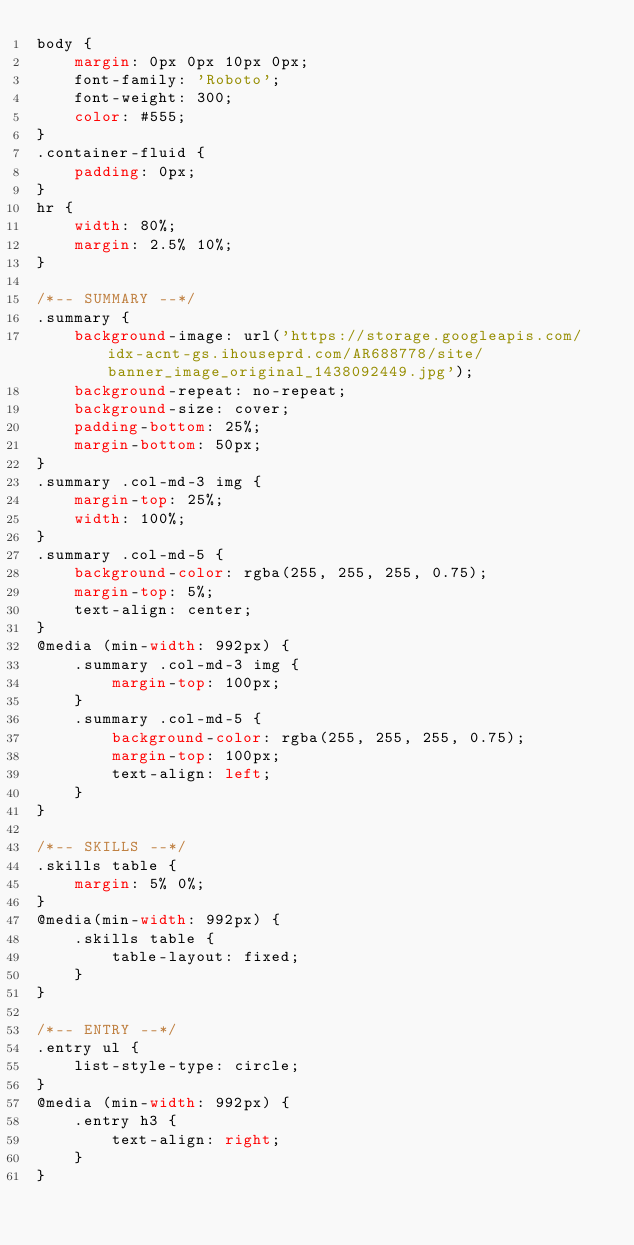<code> <loc_0><loc_0><loc_500><loc_500><_CSS_>body {
	margin: 0px 0px 10px 0px;
	font-family: 'Roboto';
	font-weight: 300;
	color: #555;
}
.container-fluid {
	padding: 0px;
}
hr {
	width: 80%;
	margin: 2.5% 10%;
}

/*-- SUMMARY --*/
.summary {
	background-image: url('https://storage.googleapis.com/idx-acnt-gs.ihouseprd.com/AR688778/site/banner_image_original_1438092449.jpg');
	background-repeat: no-repeat;
	background-size: cover;
	padding-bottom: 25%;
	margin-bottom: 50px;
}
.summary .col-md-3 img {
	margin-top: 25%;
	width: 100%;
}
.summary .col-md-5 {
	background-color: rgba(255, 255, 255, 0.75);
	margin-top: 5%;	
	text-align: center;
}
@media (min-width: 992px) {
	.summary .col-md-3 img {
		margin-top: 100px;
	}
	.summary .col-md-5 {
		background-color: rgba(255, 255, 255, 0.75);
		margin-top: 100px;
		text-align: left;
	}
}

/*-- SKILLS --*/
.skills table {
	margin: 5% 0%;
}
@media(min-width: 992px) {
	.skills table {
		table-layout: fixed;
	}
}

/*-- ENTRY --*/
.entry ul {
	list-style-type: circle;
}
@media (min-width: 992px) {
	.entry h3 {
		text-align: right;
	}
}
</code> 